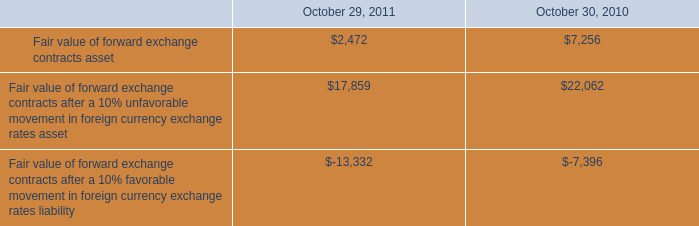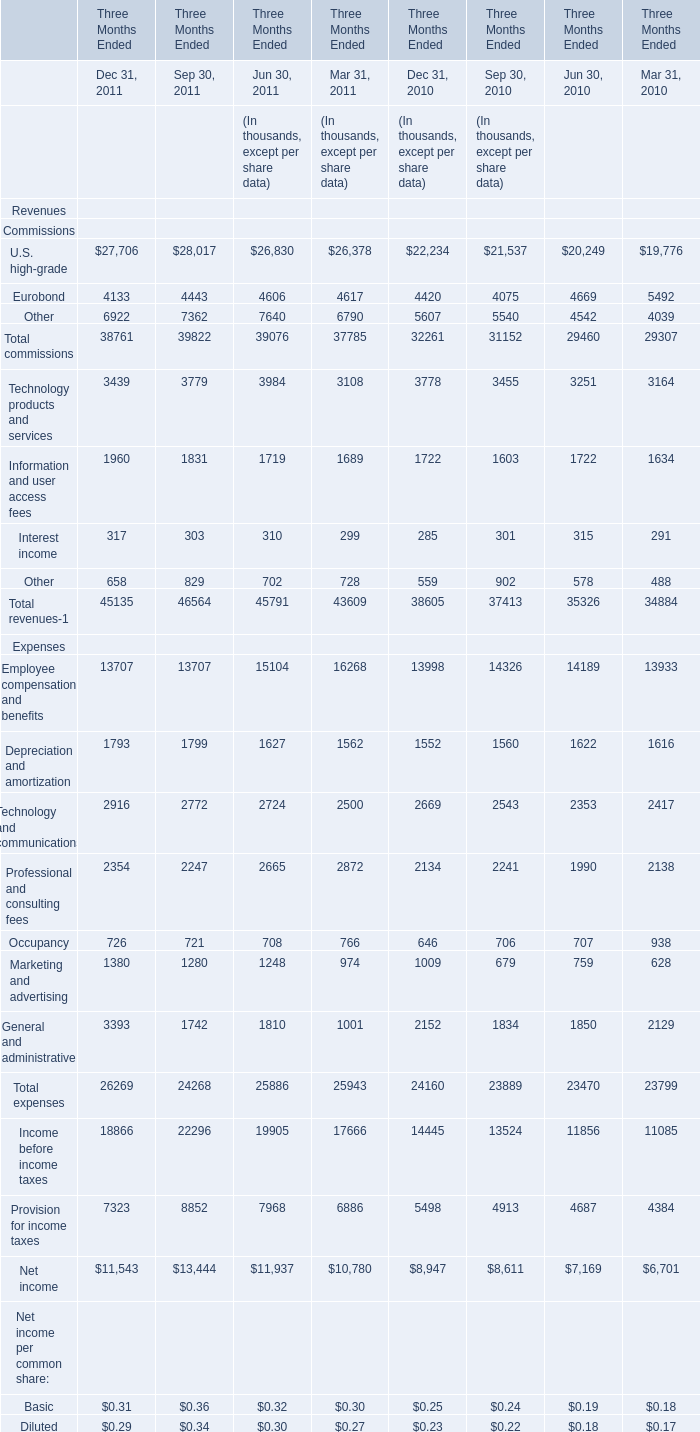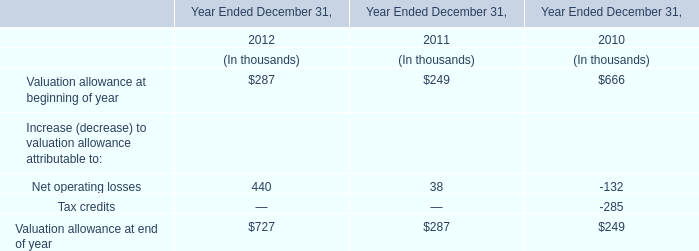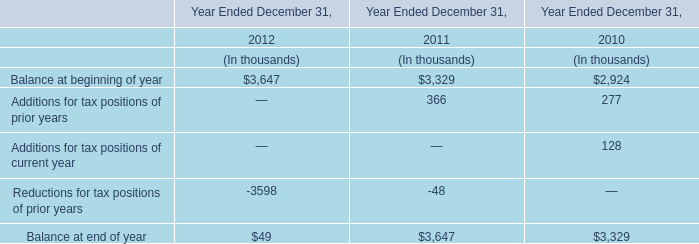What is the sum of Dec 31, 2011 in the range of 0 and 1 in 2011? (in thousand) 
Computations: (0.31 + 0.29)
Answer: 0.6. 